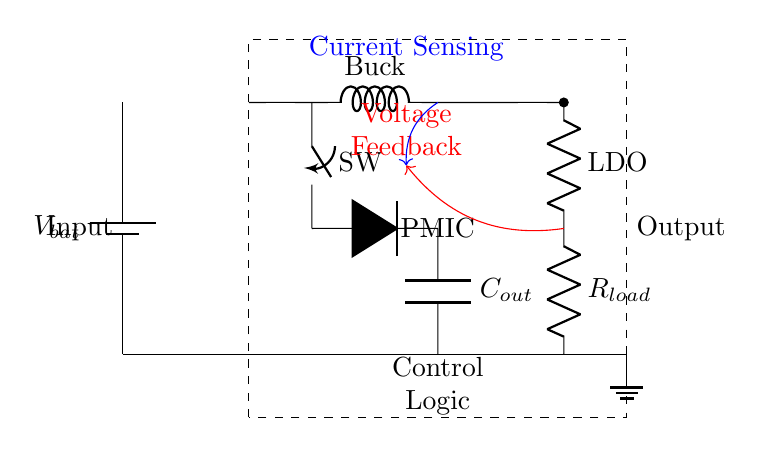What is the main component labeled in the diagram? The main component is labeled as PMIC, which stands for Power Management Integrated Circuit. It is enclosed in a dashed rectangle indicating its significance in the circuit.
Answer: PMIC What does the switch represent in this circuit? The switch in the circuit, labeled as SW, controls the flow of current to the buck converter. It can be opened or closed to allow or stop current flow.
Answer: Switch What type of converter is shown on the left side of the PMIC? The component labeled as Buck indicates that it is a buck converter, which steps down the voltage from the battery to a lower level needed for the load.
Answer: Buck converter Which component is used for voltage regulation in the circuit? The component labeled LDO represents a Low Dropout Regulator, which maintains a steady output voltage from the PMIC even if the input voltage fluctuates.
Answer: LDO How is the current sensing represented in the circuit? Current sensing is indicated by a blue arrow pointing towards the buck converter. This shows that the circuit includes a mechanism to monitor the current flowing through.
Answer: Current sensing What is the purpose of the capacitor labeled C_out? The capacitor labeled C_out is used for smoothing the output voltage by filtering out any voltage fluctuations or ripples that may occur after the buck conversion.
Answer: Smoothing output What type of feedback is used in this circuit? The feedback shown with a red arrow indicates voltage feedback, which allows the PMIC to adjust its output based on the voltage seen at the load.
Answer: Voltage feedback 